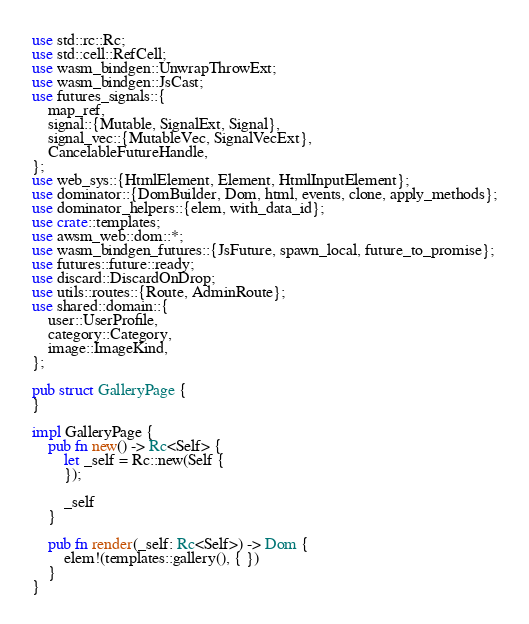<code> <loc_0><loc_0><loc_500><loc_500><_Rust_>use std::rc::Rc;
use std::cell::RefCell;
use wasm_bindgen::UnwrapThrowExt;
use wasm_bindgen::JsCast;
use futures_signals::{
    map_ref,
    signal::{Mutable, SignalExt, Signal},
    signal_vec::{MutableVec, SignalVecExt},
    CancelableFutureHandle, 
};
use web_sys::{HtmlElement, Element, HtmlInputElement};
use dominator::{DomBuilder, Dom, html, events, clone, apply_methods};
use dominator_helpers::{elem, with_data_id};
use crate::templates;
use awsm_web::dom::*;
use wasm_bindgen_futures::{JsFuture, spawn_local, future_to_promise};
use futures::future::ready;
use discard::DiscardOnDrop;
use utils::routes::{Route, AdminRoute};
use shared::domain::{
    user::UserProfile,
    category::Category,
    image::ImageKind,
};

pub struct GalleryPage {
}

impl GalleryPage {
    pub fn new() -> Rc<Self> {
        let _self = Rc::new(Self { 
        });

        _self
    }
    
    pub fn render(_self: Rc<Self>) -> Dom {
        elem!(templates::gallery(), { })
    }
}
</code> 